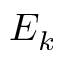<formula> <loc_0><loc_0><loc_500><loc_500>E _ { k }</formula> 